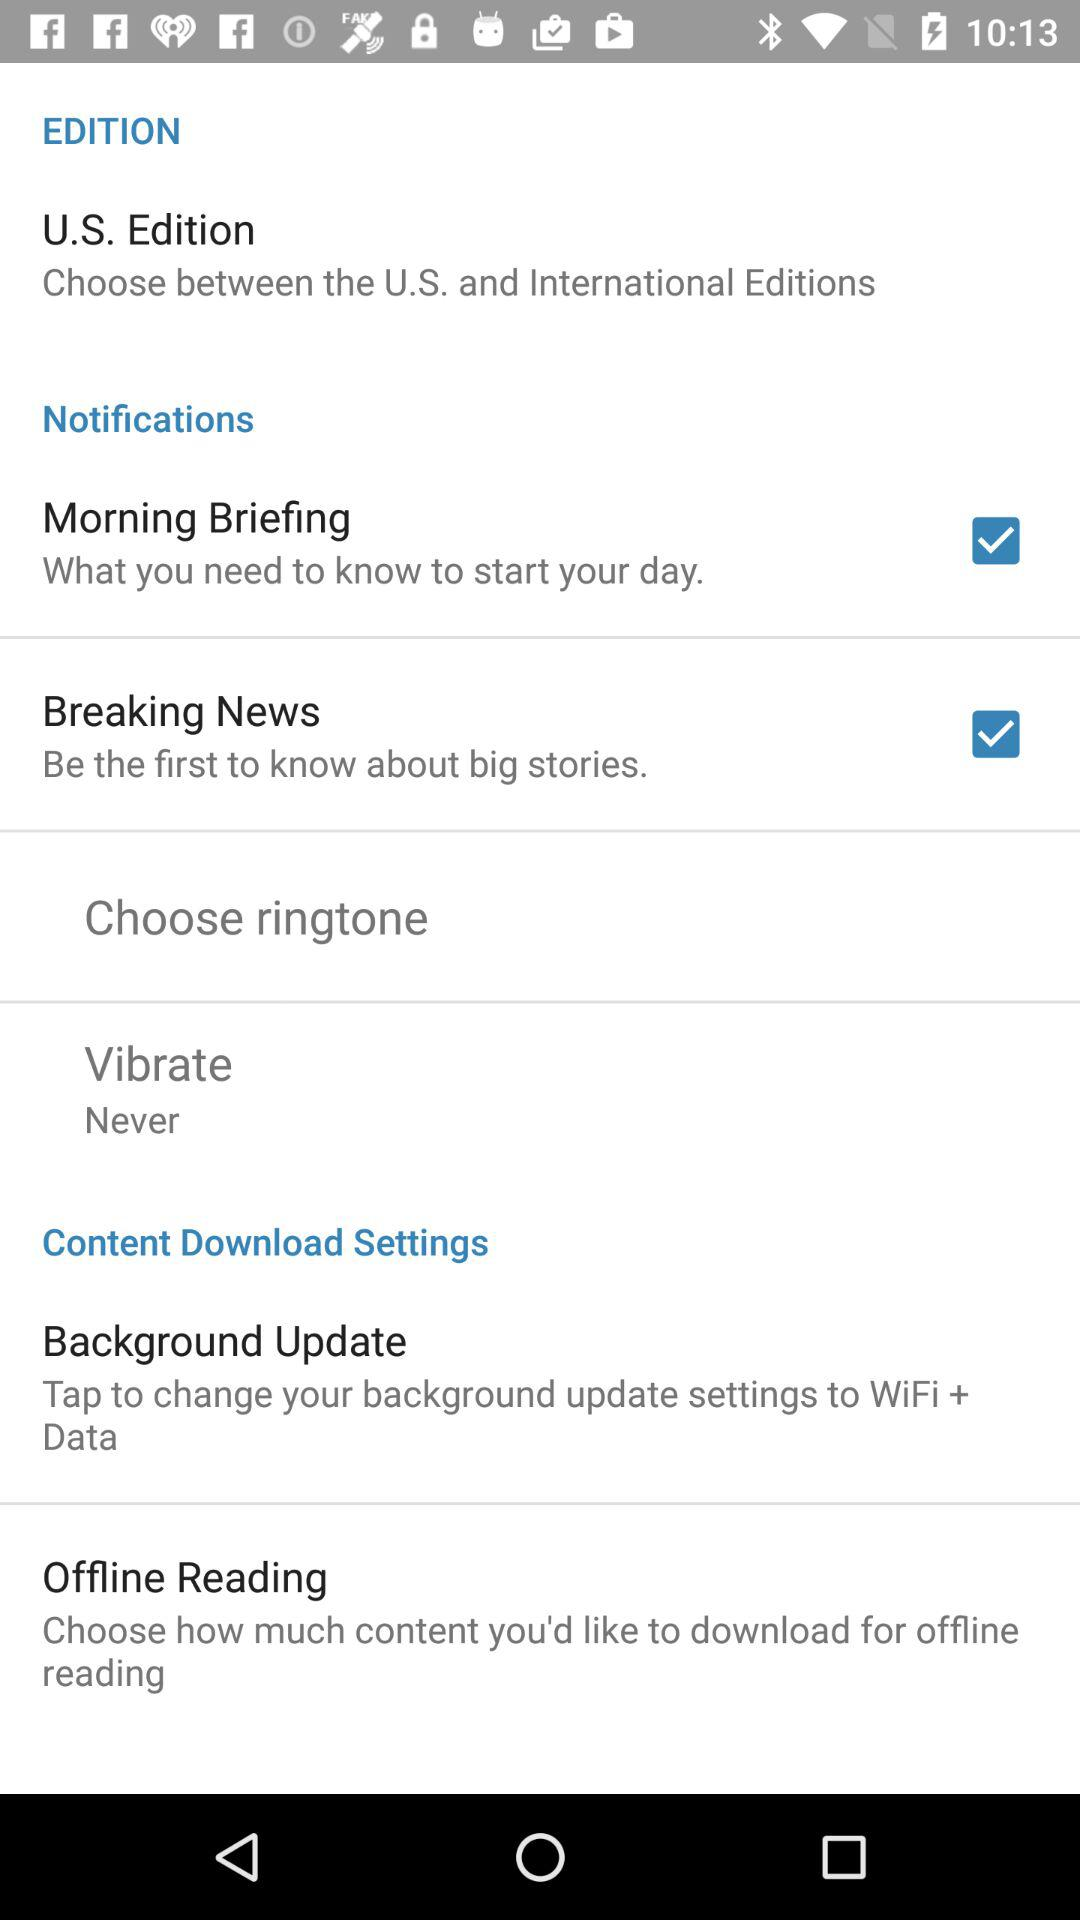What is the status of the "Breaking News"? The status of the "Breaking News" is "on". 